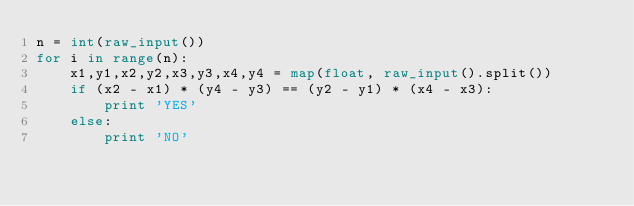Convert code to text. <code><loc_0><loc_0><loc_500><loc_500><_Python_>n = int(raw_input())
for i in range(n):
    x1,y1,x2,y2,x3,y3,x4,y4 = map(float, raw_input().split())
    if (x2 - x1) * (y4 - y3) == (y2 - y1) * (x4 - x3):
        print 'YES'
    else:
        print 'NO'</code> 